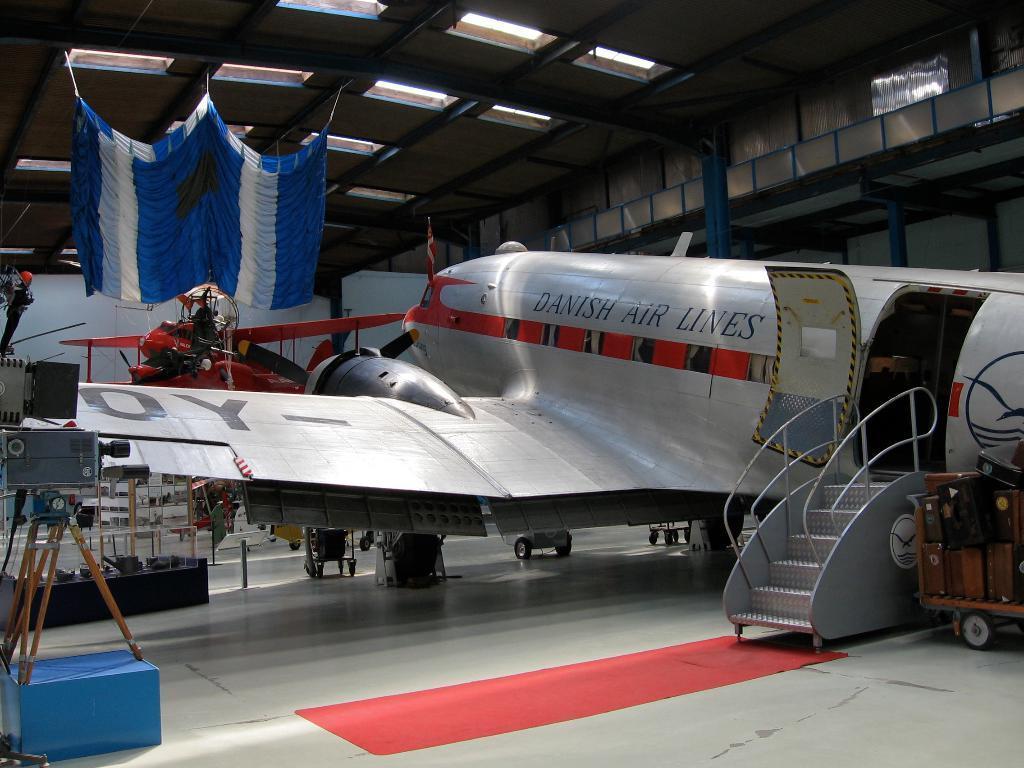Can you describe this image briefly? In this image we can see an airplane on the ground. Here we can see the ladder, trolley with luggage, tripod stand, an aircraft, curtains and lights to the ceiling in the background. 